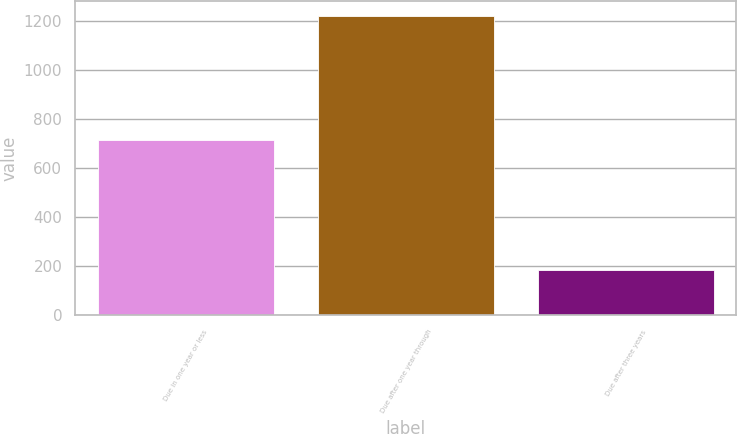Convert chart. <chart><loc_0><loc_0><loc_500><loc_500><bar_chart><fcel>Due in one year or less<fcel>Due after one year through<fcel>Due after three years<nl><fcel>716.1<fcel>1220<fcel>184.2<nl></chart> 